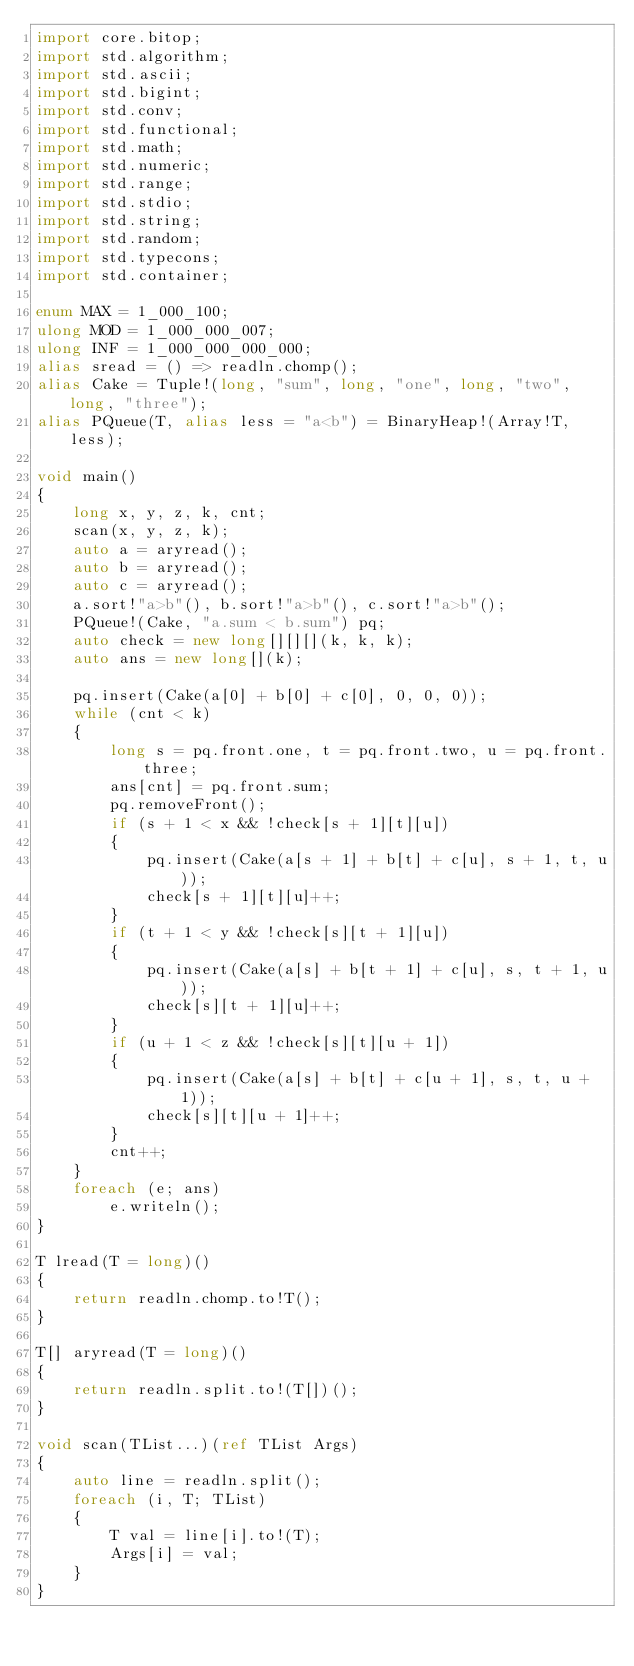<code> <loc_0><loc_0><loc_500><loc_500><_D_>import core.bitop;
import std.algorithm;
import std.ascii;
import std.bigint;
import std.conv;
import std.functional;
import std.math;
import std.numeric;
import std.range;
import std.stdio;
import std.string;
import std.random;
import std.typecons;
import std.container;

enum MAX = 1_000_100;
ulong MOD = 1_000_000_007;
ulong INF = 1_000_000_000_000;
alias sread = () => readln.chomp();
alias Cake = Tuple!(long, "sum", long, "one", long, "two", long, "three");
alias PQueue(T, alias less = "a<b") = BinaryHeap!(Array!T, less);

void main()
{
    long x, y, z, k, cnt;
    scan(x, y, z, k);
    auto a = aryread();
    auto b = aryread();
    auto c = aryread();
    a.sort!"a>b"(), b.sort!"a>b"(), c.sort!"a>b"();
    PQueue!(Cake, "a.sum < b.sum") pq;
    auto check = new long[][][](k, k, k);
    auto ans = new long[](k);

    pq.insert(Cake(a[0] + b[0] + c[0], 0, 0, 0));
    while (cnt < k)
    {
        long s = pq.front.one, t = pq.front.two, u = pq.front.three;
        ans[cnt] = pq.front.sum;
        pq.removeFront();
        if (s + 1 < x && !check[s + 1][t][u])
        {
            pq.insert(Cake(a[s + 1] + b[t] + c[u], s + 1, t, u));
            check[s + 1][t][u]++;
        }
        if (t + 1 < y && !check[s][t + 1][u])
        {
            pq.insert(Cake(a[s] + b[t + 1] + c[u], s, t + 1, u));
            check[s][t + 1][u]++;
        }
        if (u + 1 < z && !check[s][t][u + 1])
        {
            pq.insert(Cake(a[s] + b[t] + c[u + 1], s, t, u + 1));
            check[s][t][u + 1]++;
        }
        cnt++;
    }
    foreach (e; ans)
        e.writeln();
}

T lread(T = long)()
{
    return readln.chomp.to!T();
}

T[] aryread(T = long)()
{
    return readln.split.to!(T[])();
}

void scan(TList...)(ref TList Args)
{
    auto line = readln.split();
    foreach (i, T; TList)
    {
        T val = line[i].to!(T);
        Args[i] = val;
    }
}
</code> 